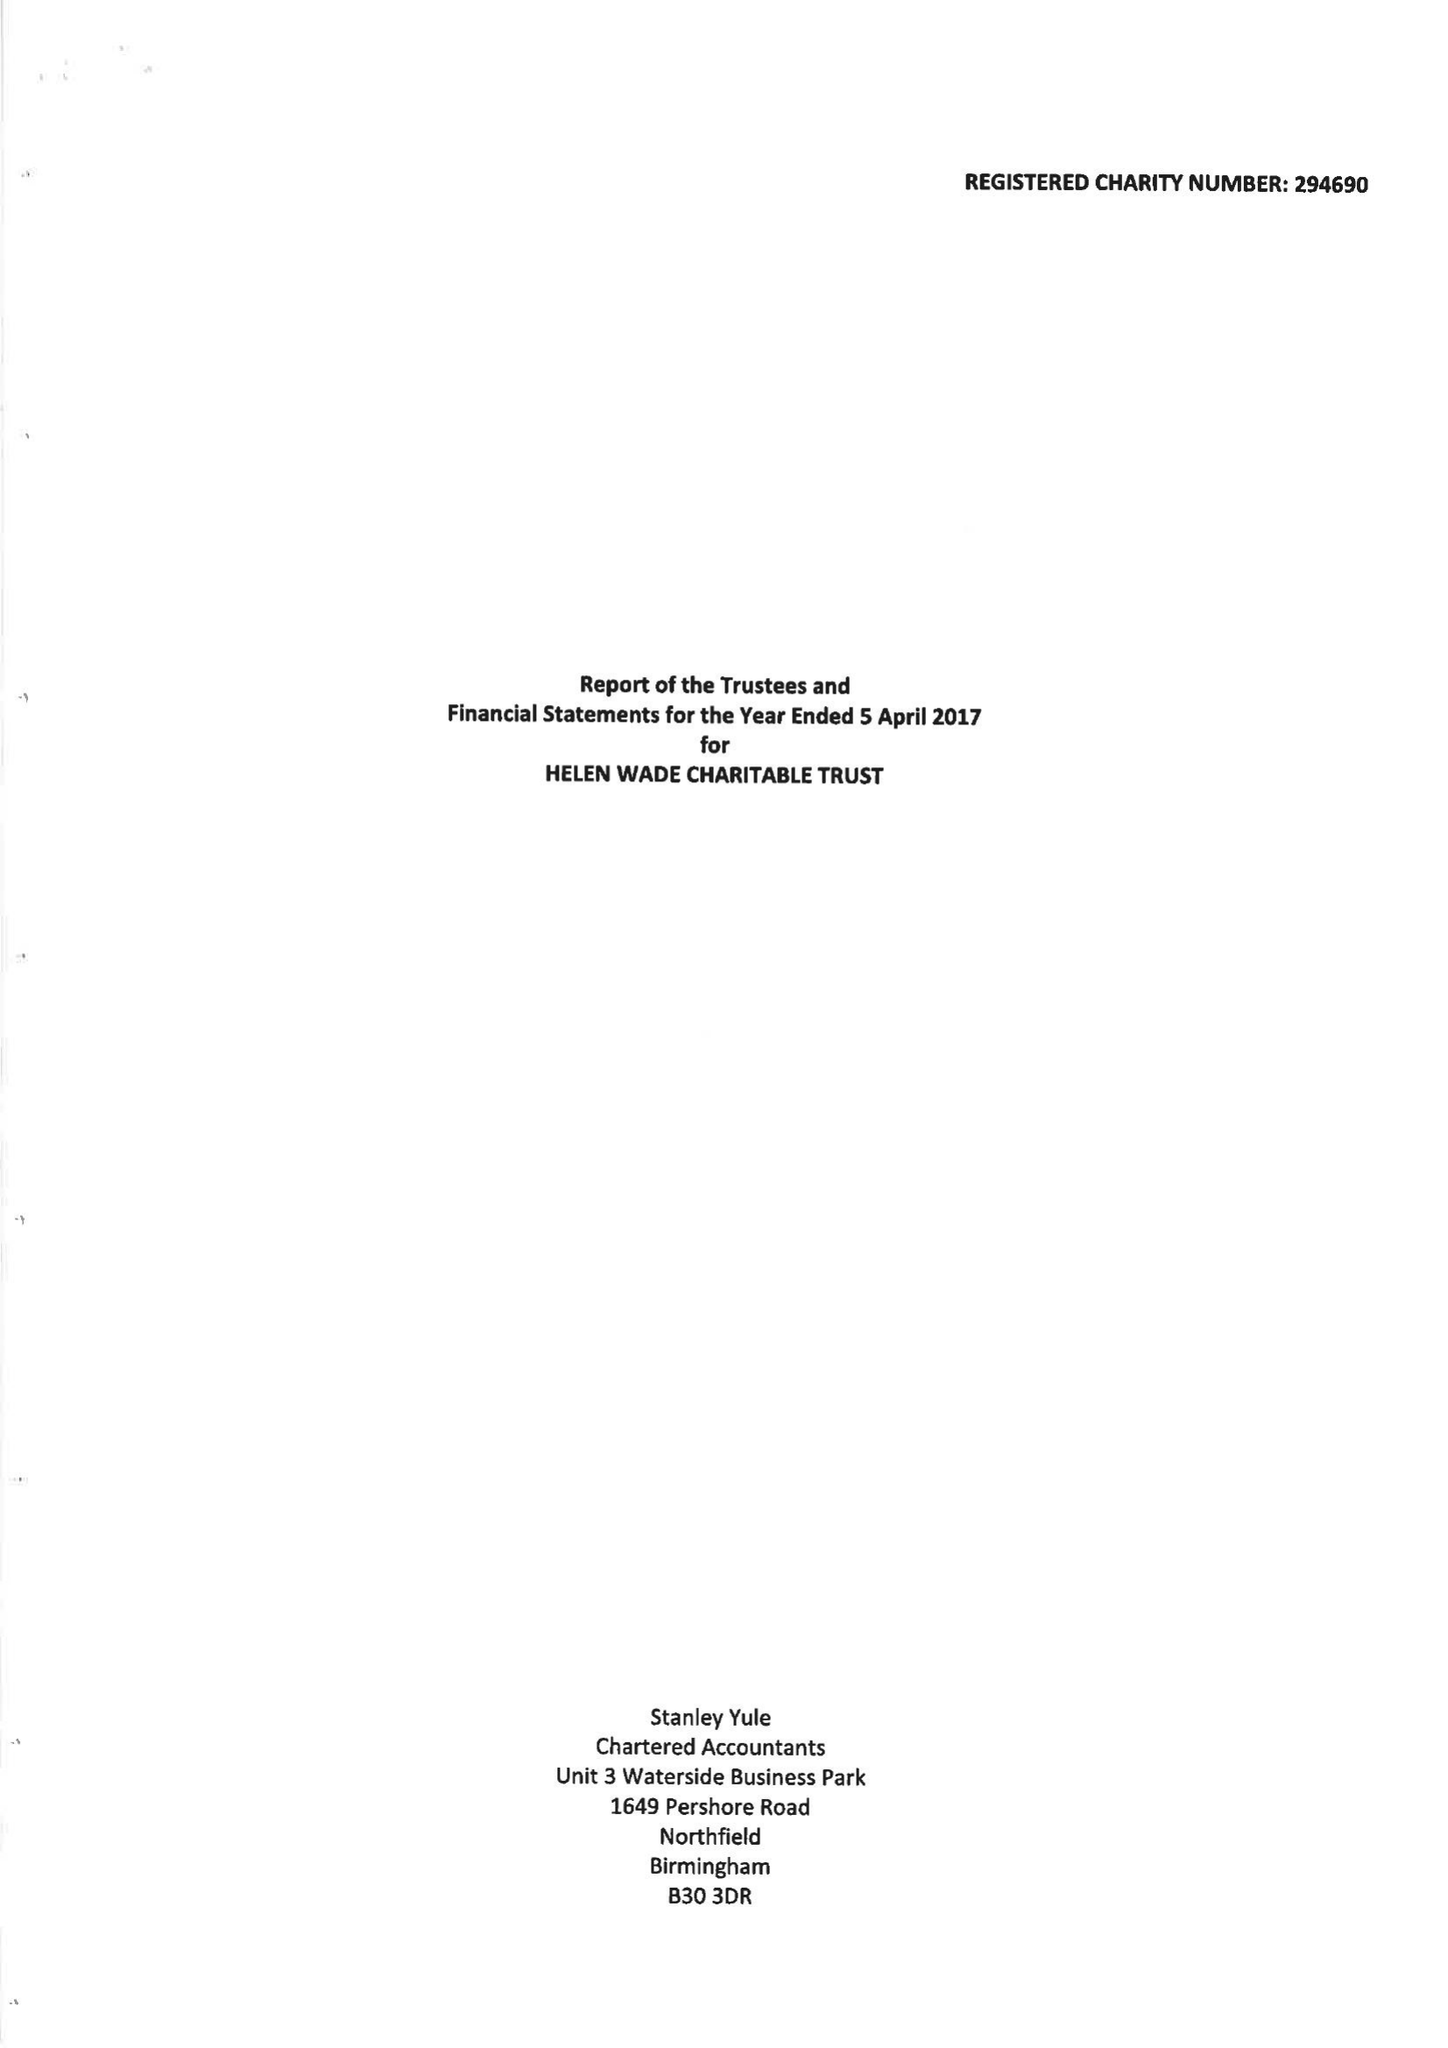What is the value for the address__street_line?
Answer the question using a single word or phrase. MOUNT EPHRAIM 